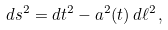Convert formula to latex. <formula><loc_0><loc_0><loc_500><loc_500>d s ^ { 2 } = d t ^ { 2 } - a ^ { 2 } ( t ) \, d \ell ^ { 2 } \, ,</formula> 